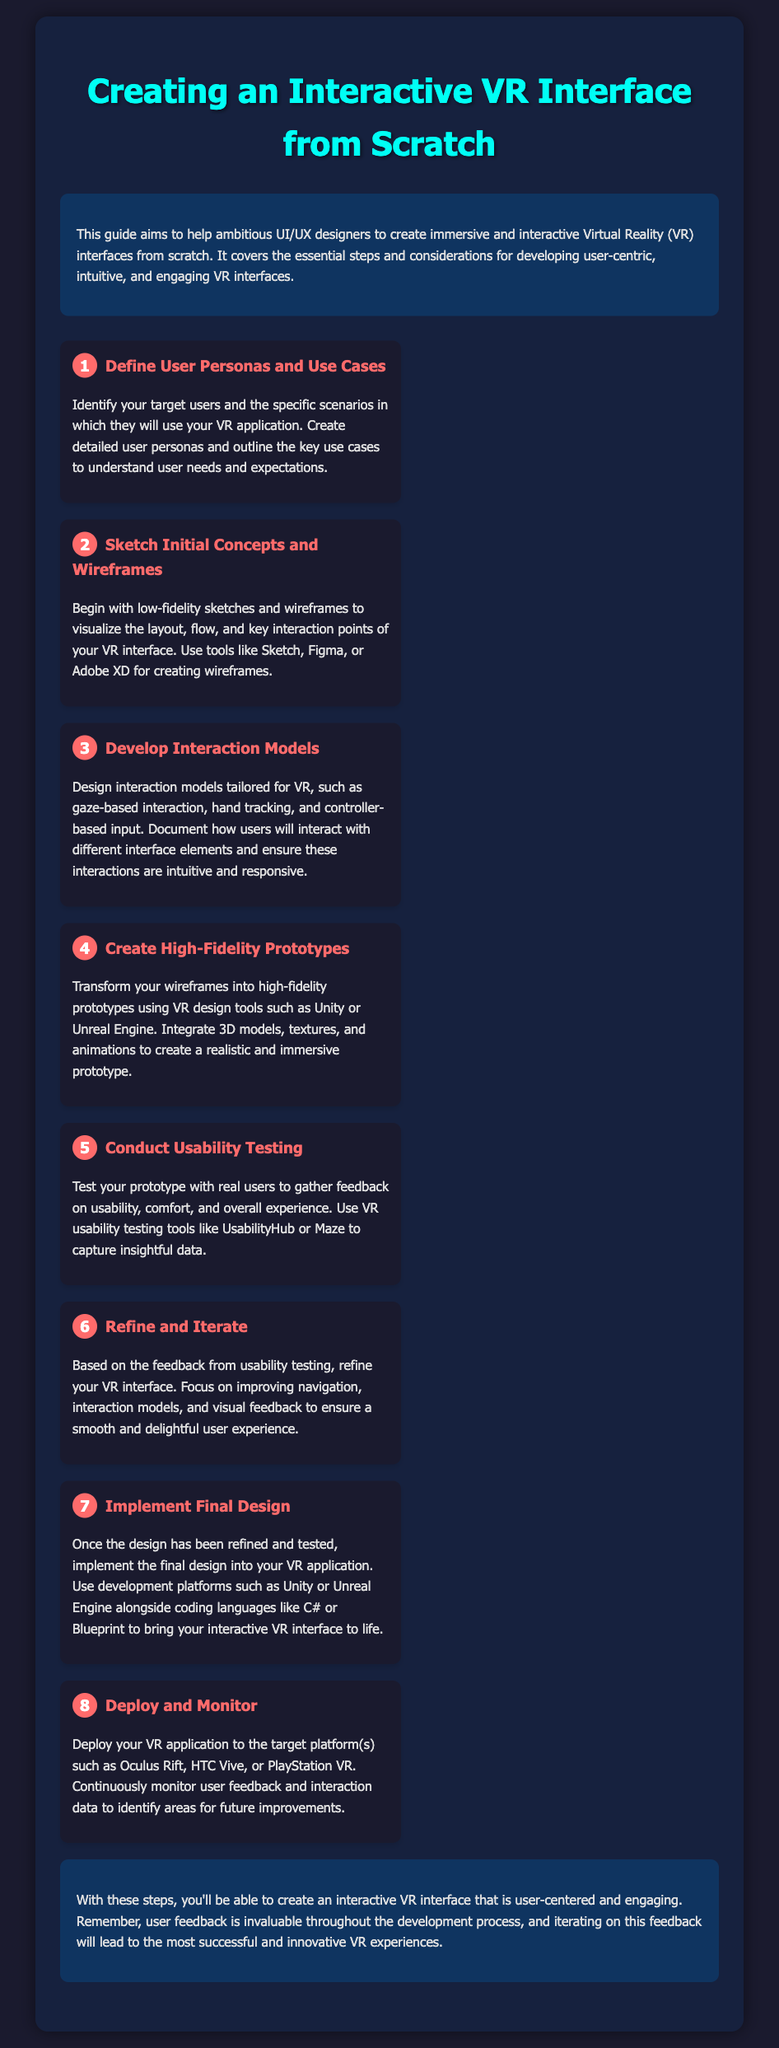What is the title of the document? The title is prominently displayed at the top of the document.
Answer: Creating an Interactive VR Interface from Scratch How many steps are there in the assembly instructions? The number of steps is listed by counting the items in the steps section.
Answer: 8 What is the primary purpose of this guide? The purpose is outlined in the introduction section of the document.
Answer: Help ambitious UI/UX designers Which VR design tools are mentioned for creating high-fidelity prototypes? The tools are referenced in the step concerning high-fidelity prototypes.
Answer: Unity or Unreal Engine What is the first step in the assembly instructions? The first step is highlighted at the beginning of the steps section.
Answer: Define User Personas and Use Cases What should be created to understand user needs and expectations? The document emphasizes creating specific items that aid understanding user requirements.
Answer: User personas Which platforms should the VR application be deployed to? The platforms are specified at the end of the deployment step.
Answer: Oculus Rift, HTC Vive, or PlayStation VR What is emphasized as invaluable throughout the development process? This valuable aspect is highlighted in the conclusion section.
Answer: User feedback 